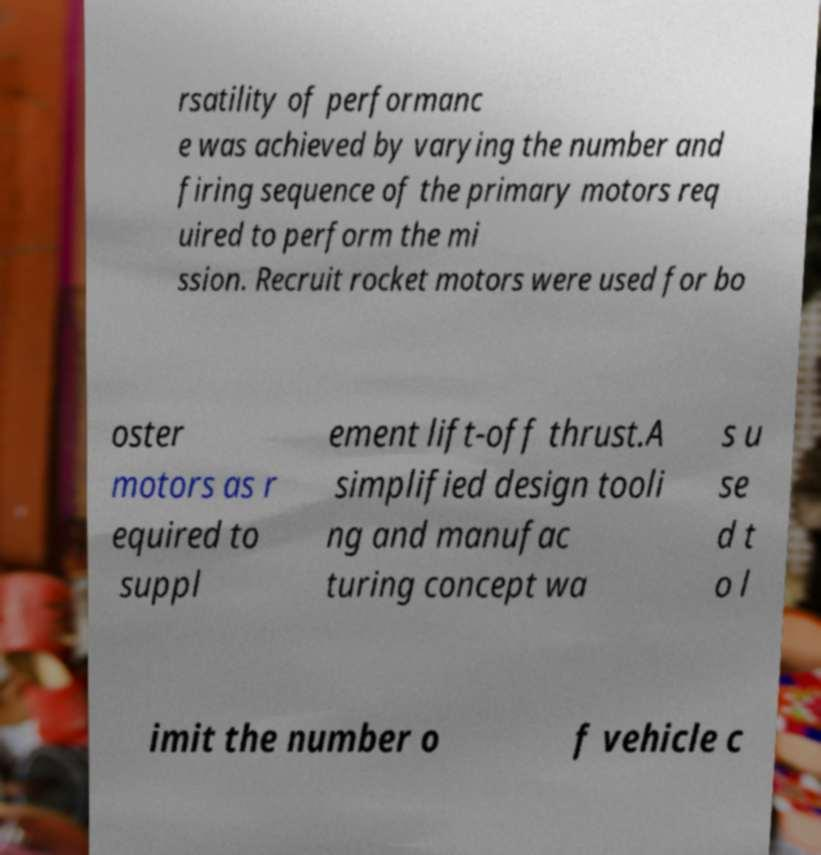Please identify and transcribe the text found in this image. rsatility of performanc e was achieved by varying the number and firing sequence of the primary motors req uired to perform the mi ssion. Recruit rocket motors were used for bo oster motors as r equired to suppl ement lift-off thrust.A simplified design tooli ng and manufac turing concept wa s u se d t o l imit the number o f vehicle c 